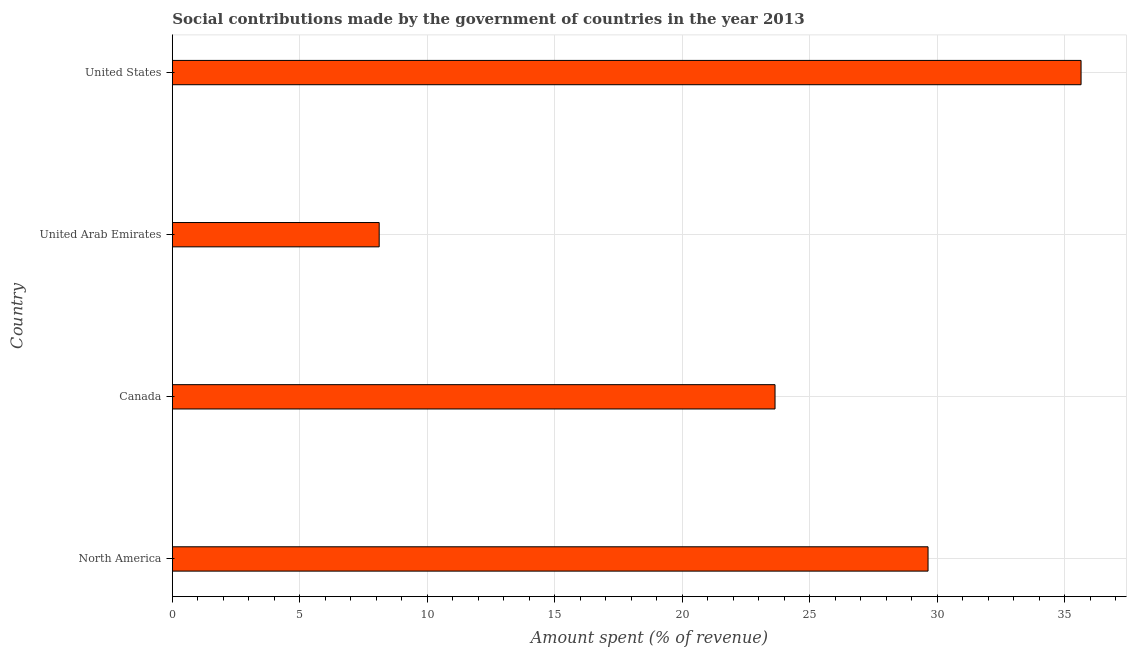Does the graph contain any zero values?
Keep it short and to the point. No. What is the title of the graph?
Your response must be concise. Social contributions made by the government of countries in the year 2013. What is the label or title of the X-axis?
Give a very brief answer. Amount spent (% of revenue). What is the label or title of the Y-axis?
Keep it short and to the point. Country. What is the amount spent in making social contributions in United States?
Provide a short and direct response. 35.64. Across all countries, what is the maximum amount spent in making social contributions?
Your answer should be compact. 35.64. Across all countries, what is the minimum amount spent in making social contributions?
Your response must be concise. 8.11. In which country was the amount spent in making social contributions minimum?
Provide a succinct answer. United Arab Emirates. What is the sum of the amount spent in making social contributions?
Make the answer very short. 97.04. What is the difference between the amount spent in making social contributions in Canada and United States?
Offer a terse response. -12. What is the average amount spent in making social contributions per country?
Give a very brief answer. 24.26. What is the median amount spent in making social contributions?
Ensure brevity in your answer.  26.64. What is the ratio of the amount spent in making social contributions in Canada to that in United Arab Emirates?
Make the answer very short. 2.91. What is the difference between the highest and the second highest amount spent in making social contributions?
Give a very brief answer. 6. What is the difference between the highest and the lowest amount spent in making social contributions?
Offer a terse response. 27.53. How many countries are there in the graph?
Provide a succinct answer. 4. What is the Amount spent (% of revenue) of North America?
Offer a very short reply. 29.64. What is the Amount spent (% of revenue) in Canada?
Offer a very short reply. 23.64. What is the Amount spent (% of revenue) of United Arab Emirates?
Provide a succinct answer. 8.11. What is the Amount spent (% of revenue) of United States?
Provide a short and direct response. 35.64. What is the difference between the Amount spent (% of revenue) in North America and Canada?
Your answer should be very brief. 6. What is the difference between the Amount spent (% of revenue) in North America and United Arab Emirates?
Keep it short and to the point. 21.53. What is the difference between the Amount spent (% of revenue) in North America and United States?
Ensure brevity in your answer.  -6. What is the difference between the Amount spent (% of revenue) in Canada and United Arab Emirates?
Keep it short and to the point. 15.53. What is the difference between the Amount spent (% of revenue) in Canada and United States?
Your answer should be compact. -12. What is the difference between the Amount spent (% of revenue) in United Arab Emirates and United States?
Provide a short and direct response. -27.53. What is the ratio of the Amount spent (% of revenue) in North America to that in Canada?
Your answer should be very brief. 1.25. What is the ratio of the Amount spent (% of revenue) in North America to that in United Arab Emirates?
Your response must be concise. 3.65. What is the ratio of the Amount spent (% of revenue) in North America to that in United States?
Your response must be concise. 0.83. What is the ratio of the Amount spent (% of revenue) in Canada to that in United Arab Emirates?
Provide a succinct answer. 2.91. What is the ratio of the Amount spent (% of revenue) in Canada to that in United States?
Your response must be concise. 0.66. What is the ratio of the Amount spent (% of revenue) in United Arab Emirates to that in United States?
Provide a succinct answer. 0.23. 